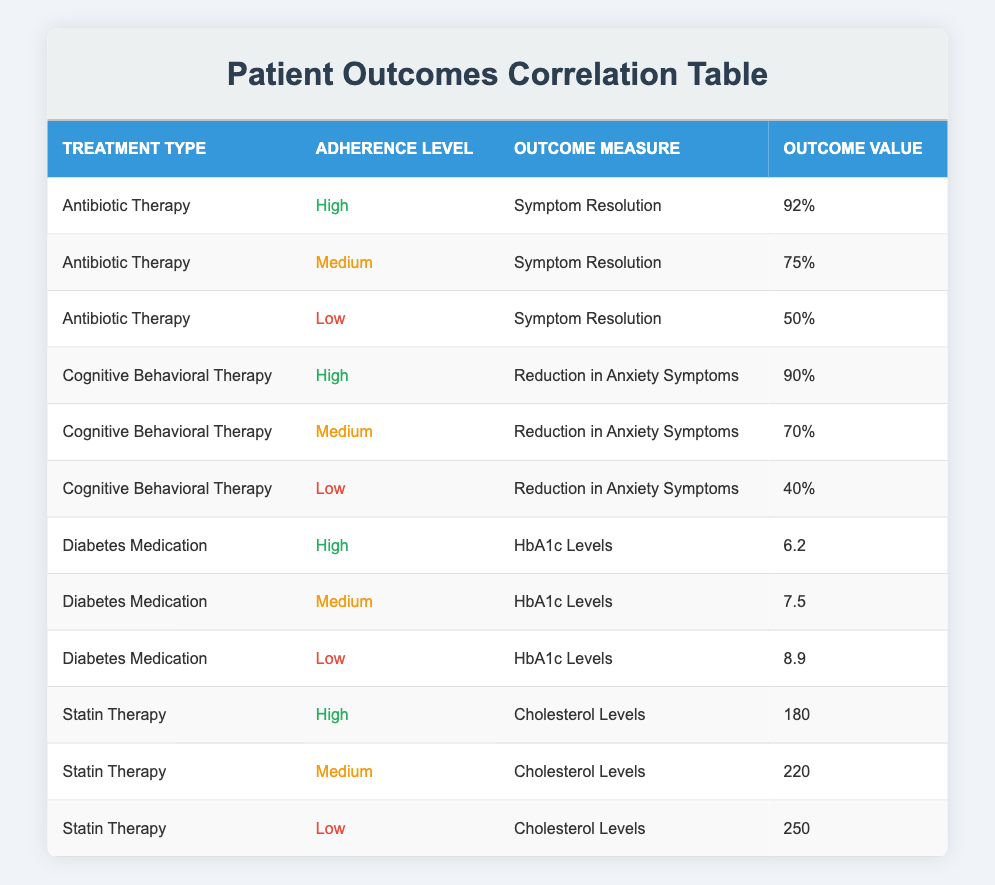What is the outcome value for Antibiotic Therapy with high adherence? According to the table, the outcome value for Antibiotic Therapy with high adherence is 92%.
Answer: 92% What is the lowest outcome value reported for Cognitive Behavioral Therapy? The table shows that the lowest outcome value for Cognitive Behavioral Therapy is 40% for low adherence.
Answer: 40% What is the average outcome value for high adherence across all treatment types? To calculate the average for high adherence: (92 + 90 + 6.2 + 180) / 4 = 92.05. Thus, the average outcome value for high adherence is 92.05.
Answer: 92.05 Is the outcome value for medium adherence in Diabetes Medication lower than that in Statin Therapy for medium adherence? The table shows that the outcome value for medium adherence in Diabetes Medication is 7.5, while for Statin Therapy it is 220. Since 7.5 is lower than 220, the answer is yes.
Answer: Yes What is the difference between the outcome values for low and high adherence in Diabetes Medication? The outcome value for Diabetes Medication with low adherence is 8.9, and for high adherence, it is 6.2. The difference is 8.9 - 6.2 = 2.7.
Answer: 2.7 What treatment type has the highest outcome value overall? By comparing all outcome values: Antibiotic Therapy high (92), Cognitive Behavioral Therapy high (90), Diabetes Medication high (6.2), and Statin Therapy high (180), Antibiotic Therapy has the highest value of 92%.
Answer: Antibiotic Therapy What is the total of outcome values for all high adherence treatment types? The total for high adherence outcomes is calculated as follows: 92% (Antibiotic) + 90% (Cognitive) + 6.2 (Diabetes) + 180 (Statin) = 368.2.
Answer: 368.2 Is the HbA1c level of low adherence in Diabetes Medication greater than that of high adherence? The HbA1c level for low adherence is 8.9, while for high adherence, it is 6.2. Since 8.9 is greater than 6.2, the answer is yes.
Answer: Yes What outcome value is associated with medium adherence in Antibiotic Therapy? The table indicates that the outcome value for medium adherence in Antibiotic Therapy is 75%.
Answer: 75% 